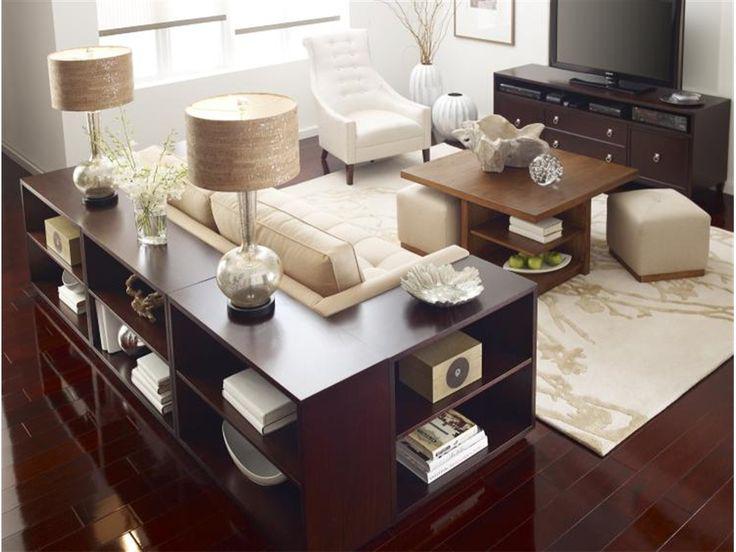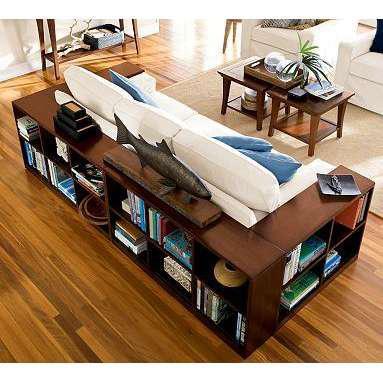The first image is the image on the left, the second image is the image on the right. For the images displayed, is the sentence "In at least one image there is a bookshelf couch with no more than three deep blue pillows." factually correct? Answer yes or no. Yes. The first image is the image on the left, the second image is the image on the right. Analyze the images presented: Is the assertion "The left image shows a woodgrain shelving unit that wraps around the back and side of a couch, with two lamps on its top." valid? Answer yes or no. Yes. 